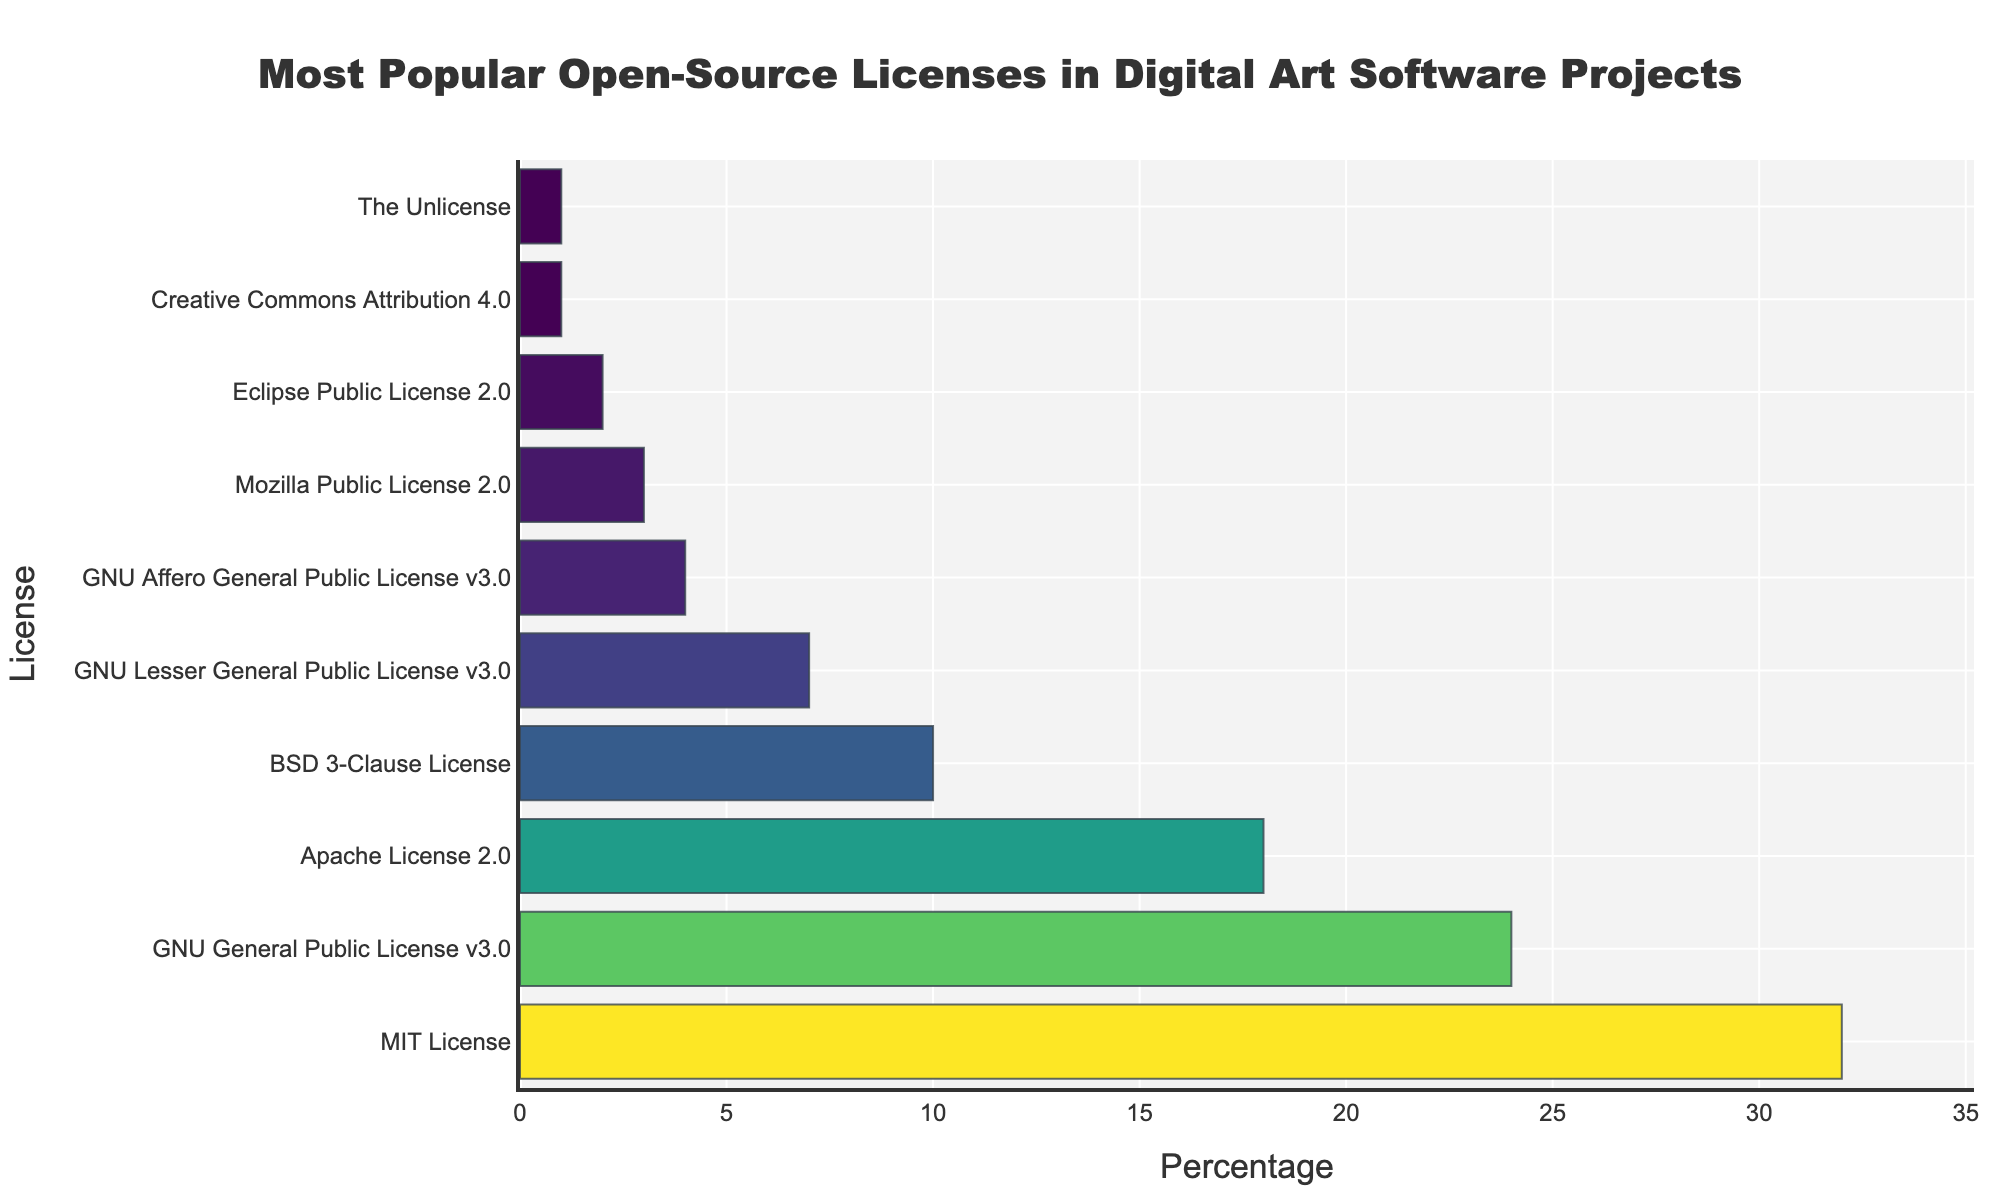Which license is the most popular in digital art software projects? The most popular license will be the one with the highest percentage. In the bar chart, the MIT License has the highest percentage at 32%.
Answer: MIT License What is the combined percentage of projects using GNU licenses (GPL v3.0, LGPL v3.0, AGPL v3.0)? Sum the percentages of GNU General Public License v3.0 (24%), GNU Lesser General Public License v3.0 (7%), and GNU Affero General Public License v3.0 (4%). So, 24 + 7 + 4 = 35%.
Answer: 35% Which license has the smallest representation in digital art software projects? The license with the smallest representation will have the lowest percentage. In the bar chart, both Creative Commons Attribution 4.0 and The Unlicense have the lowest percentage at 1%.
Answer: Creative Commons Attribution 4.0 and The Unlicense How much more popular is the MIT License compared to the BSD 3-Clause License? Find the difference in their percentages: MIT License (32%) - BSD 3-Clause License (10%) = 22%.
Answer: 22% What is the average percentage of the three least popular licenses? The three least popular licenses are Mozilla Public License 2.0 (3%), Eclipse Public License 2.0 (2%), and Creative Commons Attribution 4.0 (1%). Average = (3 + 2 + 1) / 3 = 6 / 3 = 2%.
Answer: 2% Which license ranks just below the Apache License 2.0 in terms of popularity? The Apache License 2.0 has a percentage of 18%. The next license with a lower percentage is the BSD 3-Clause License at 10%.
Answer: BSD 3-Clause License How many licenses have a percentage higher than 10%? Count all the licenses that have a percentage value greater than 10%. These are: MIT License (32%), GNU General Public License v3.0 (24%), and Apache License 2.0 (18%). So, there are 3 licenses.
Answer: 3 Is the percentage of projects using the Mozilla Public License 2.0 greater than or less than that of Eclipse Public License 2.0? Compare the percentages: Mozilla Public License 2.0 (3%) and Eclipse Public License 2.0 (2%). 3% is greater than 2%.
Answer: Greater What is the visual difference in color intensity between the largest and smallest bars? The bar representing the MIT License (32%) will have the most intense color in the Viridis colorscale, while the bars for Creative Commons Attribution 4.0 and The Unlicense (both 1%) will have the least intense color.
Answer: Most intense vs. least intense 